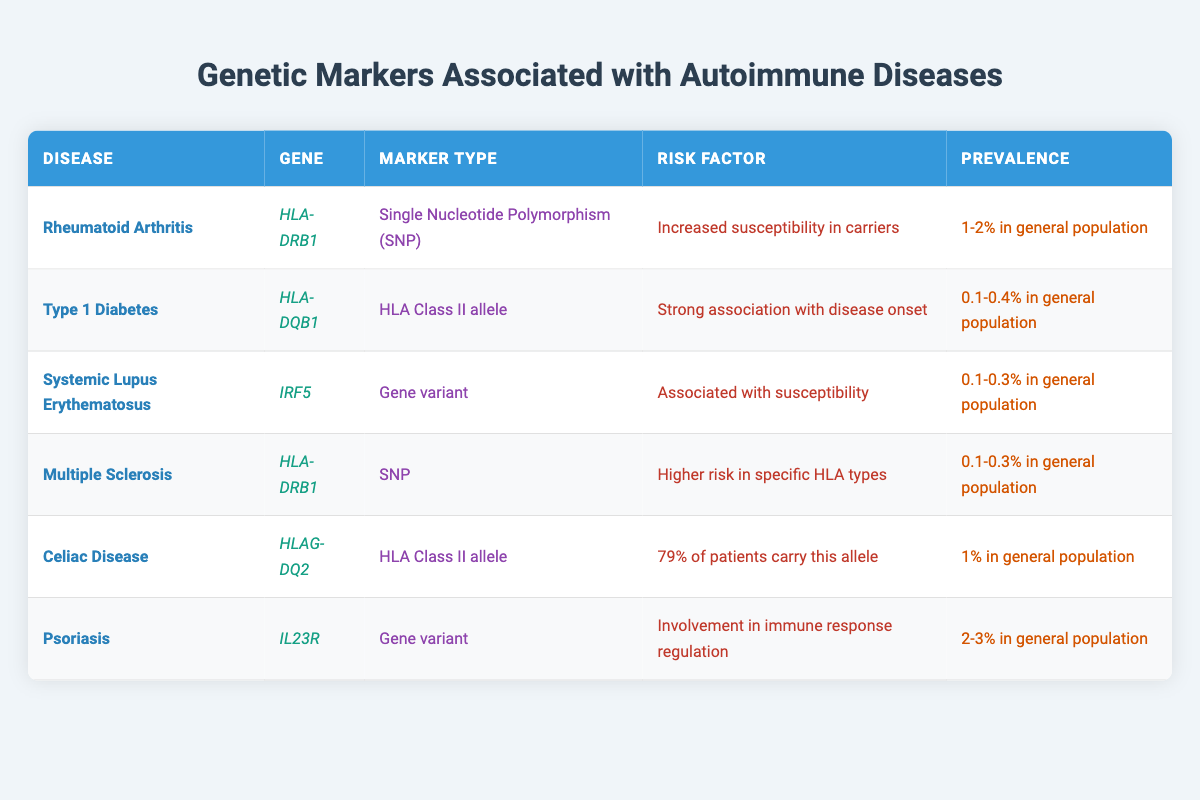What genetic marker is associated with Celiac Disease? Celiac Disease is associated with the gene HLAG-DQ2. This information is taken directly from the corresponding row in the table.
Answer: HLAG-DQ2 What is the risk factor for Systemic Lupus Erythematosus? The risk factor for Systemic Lupus Erythematosus as per the table is "Associated with susceptibility". This is listed in the risk factor column for that disease.
Answer: Associated with susceptibility Which autoimmune disease has the highest prevalence in the general population? To answer this, we compare the prevalence values listed in the table. Psoriasis has a prevalence of 2-3%, which is higher than all other diseases listed.
Answer: Psoriasis Is HLA-DRB1 associated with only one autoimmune disease? The table shows that HLA-DRB1 is associated with two diseases: Rheumatoid Arthritis and Multiple Sclerosis. Therefore, the statement is false.
Answer: No What is the average prevalence of autoimmune diseases listed in the table? First, we need to convert the prevalence percentages into numeric values where applicable: Rheumatoid Arthritis (1.5), Type 1 Diabetes (0.25), Systemic Lupus Erythematosus (0.2), Multiple Sclerosis (0.2), Celiac Disease (1), and Psoriasis (2.5). The sum is 5.7 and dividing by 6 gives an average of 0.95%.
Answer: 0.95% Which gene has a strong association with disease onset? The table indicates that the gene HLA-DQB1 is strongly associated with the disease onset of Type 1 Diabetes. This is found in the risk factor column in that row.
Answer: HLA-DQB1 Is there any autoimmune disease in the table with a prevalence of less than 0.2%? Looking at the prevalence figures, both Systemic Lupus Erythematosus and Multiple Sclerosis have a prevalence of 0.1-0.3%. Their minimum value of 0.1% is indeed below 0.2%, which confirms that there are diseases with a prevalence of less than 0.2%.
Answer: Yes What is the risk factor for Psoriasis? From the table, we look specifically at the risk factor listed for Psoriasis, which is "Involvement in immune response regulation." This is directly referenced in the table.
Answer: Involvement in immune response regulation 